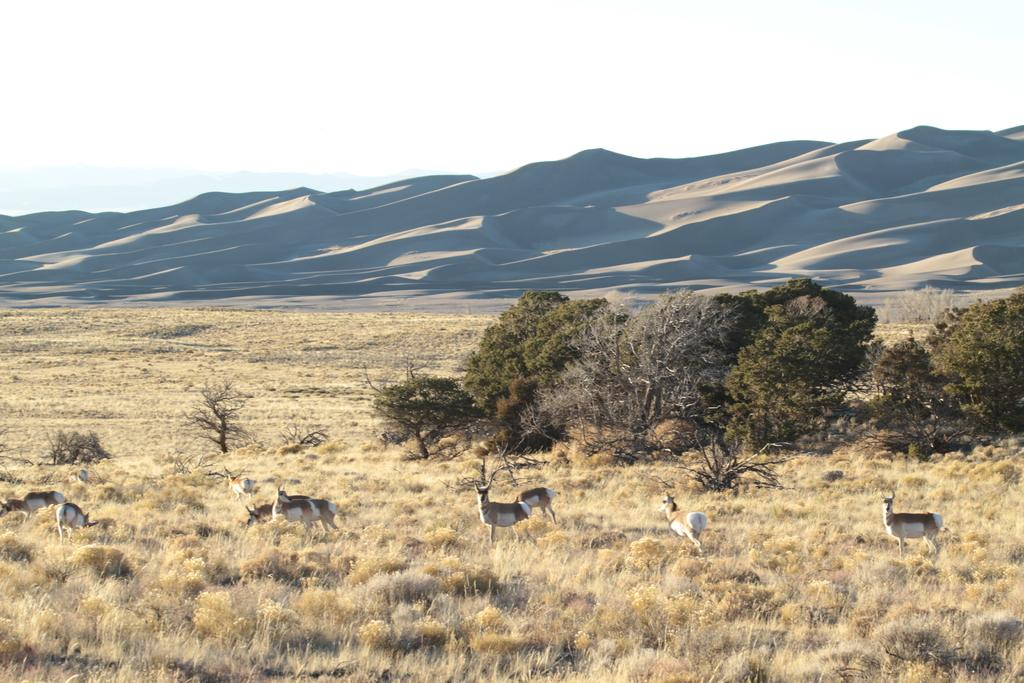What types of living organisms can be seen in the image? There are animals in the image. What is the ground covered with? The ground is covered with grass. What other natural elements are present in the image? Plants and trees are visible in the image. What type of terrain can be seen in the image? There are hills in the image. What part of the natural environment is visible in the image? The sky is visible in the image. What type of carriage can be seen being used by the cook in the image? There is no carriage or cook present in the image. 